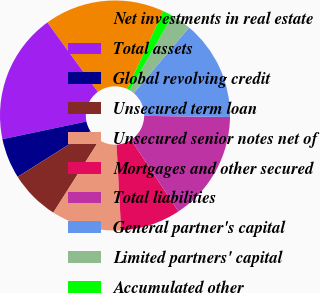Convert chart to OTSL. <chart><loc_0><loc_0><loc_500><loc_500><pie_chart><fcel>Net investments in real estate<fcel>Total assets<fcel>Global revolving credit<fcel>Unsecured term loan<fcel>Unsecured senior notes net of<fcel>Mortgages and other secured<fcel>Total liabilities<fcel>General partner's capital<fcel>Limited partners' capital<fcel>Accumulated other<nl><fcel>16.89%<fcel>18.3%<fcel>5.64%<fcel>7.05%<fcel>9.86%<fcel>8.45%<fcel>15.49%<fcel>14.08%<fcel>2.82%<fcel>1.42%<nl></chart> 